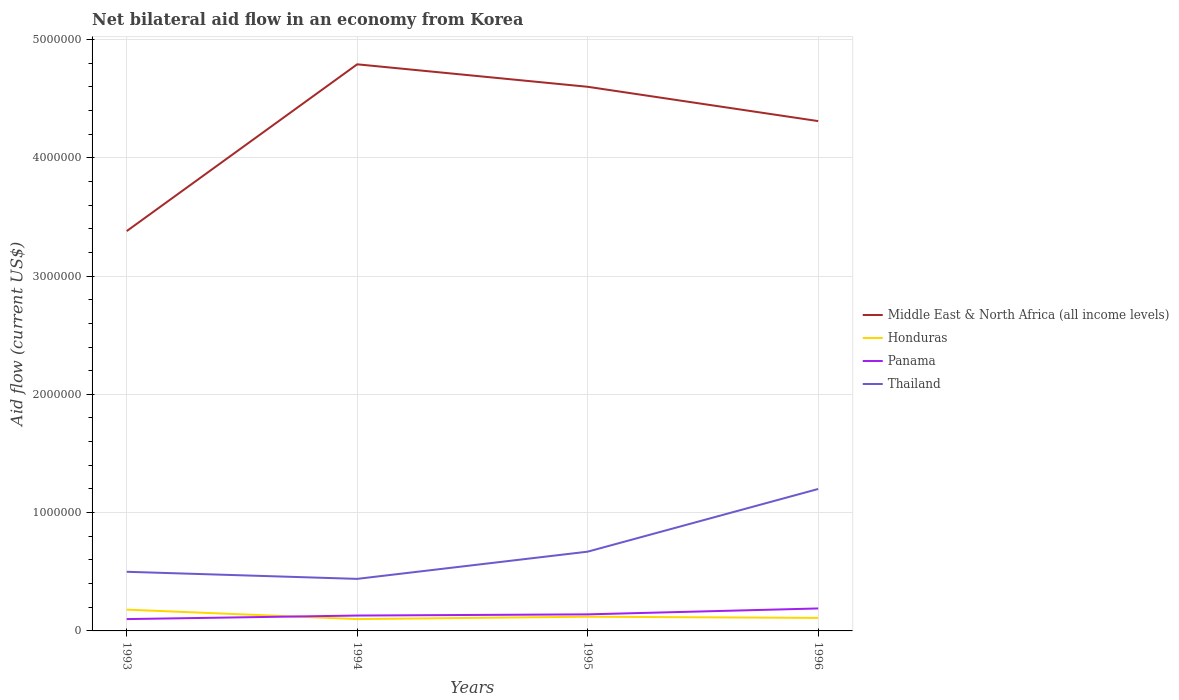In which year was the net bilateral aid flow in Panama maximum?
Keep it short and to the point. 1993. What is the total net bilateral aid flow in Panama in the graph?
Keep it short and to the point. -10000. How many lines are there?
Offer a terse response. 4. What is the difference between two consecutive major ticks on the Y-axis?
Your answer should be very brief. 1.00e+06. Does the graph contain any zero values?
Offer a terse response. No. What is the title of the graph?
Give a very brief answer. Net bilateral aid flow in an economy from Korea. Does "High income: OECD" appear as one of the legend labels in the graph?
Offer a terse response. No. What is the label or title of the Y-axis?
Give a very brief answer. Aid flow (current US$). What is the Aid flow (current US$) in Middle East & North Africa (all income levels) in 1993?
Provide a succinct answer. 3.38e+06. What is the Aid flow (current US$) of Panama in 1993?
Make the answer very short. 1.00e+05. What is the Aid flow (current US$) of Middle East & North Africa (all income levels) in 1994?
Offer a very short reply. 4.79e+06. What is the Aid flow (current US$) of Panama in 1994?
Your response must be concise. 1.30e+05. What is the Aid flow (current US$) in Middle East & North Africa (all income levels) in 1995?
Provide a short and direct response. 4.60e+06. What is the Aid flow (current US$) in Honduras in 1995?
Ensure brevity in your answer.  1.20e+05. What is the Aid flow (current US$) in Panama in 1995?
Provide a succinct answer. 1.40e+05. What is the Aid flow (current US$) of Thailand in 1995?
Provide a succinct answer. 6.70e+05. What is the Aid flow (current US$) of Middle East & North Africa (all income levels) in 1996?
Provide a short and direct response. 4.31e+06. What is the Aid flow (current US$) of Thailand in 1996?
Your answer should be compact. 1.20e+06. Across all years, what is the maximum Aid flow (current US$) in Middle East & North Africa (all income levels)?
Provide a succinct answer. 4.79e+06. Across all years, what is the maximum Aid flow (current US$) of Panama?
Provide a short and direct response. 1.90e+05. Across all years, what is the maximum Aid flow (current US$) in Thailand?
Your response must be concise. 1.20e+06. Across all years, what is the minimum Aid flow (current US$) in Middle East & North Africa (all income levels)?
Provide a succinct answer. 3.38e+06. Across all years, what is the minimum Aid flow (current US$) of Honduras?
Your answer should be compact. 1.00e+05. Across all years, what is the minimum Aid flow (current US$) of Panama?
Give a very brief answer. 1.00e+05. What is the total Aid flow (current US$) of Middle East & North Africa (all income levels) in the graph?
Make the answer very short. 1.71e+07. What is the total Aid flow (current US$) of Honduras in the graph?
Offer a very short reply. 5.10e+05. What is the total Aid flow (current US$) in Panama in the graph?
Keep it short and to the point. 5.60e+05. What is the total Aid flow (current US$) in Thailand in the graph?
Offer a very short reply. 2.81e+06. What is the difference between the Aid flow (current US$) in Middle East & North Africa (all income levels) in 1993 and that in 1994?
Keep it short and to the point. -1.41e+06. What is the difference between the Aid flow (current US$) of Panama in 1993 and that in 1994?
Your answer should be compact. -3.00e+04. What is the difference between the Aid flow (current US$) of Middle East & North Africa (all income levels) in 1993 and that in 1995?
Your answer should be very brief. -1.22e+06. What is the difference between the Aid flow (current US$) in Panama in 1993 and that in 1995?
Ensure brevity in your answer.  -4.00e+04. What is the difference between the Aid flow (current US$) in Thailand in 1993 and that in 1995?
Your response must be concise. -1.70e+05. What is the difference between the Aid flow (current US$) in Middle East & North Africa (all income levels) in 1993 and that in 1996?
Offer a terse response. -9.30e+05. What is the difference between the Aid flow (current US$) of Panama in 1993 and that in 1996?
Offer a very short reply. -9.00e+04. What is the difference between the Aid flow (current US$) of Thailand in 1993 and that in 1996?
Your response must be concise. -7.00e+05. What is the difference between the Aid flow (current US$) of Middle East & North Africa (all income levels) in 1994 and that in 1995?
Provide a succinct answer. 1.90e+05. What is the difference between the Aid flow (current US$) of Honduras in 1994 and that in 1995?
Your answer should be very brief. -2.00e+04. What is the difference between the Aid flow (current US$) in Thailand in 1994 and that in 1995?
Provide a short and direct response. -2.30e+05. What is the difference between the Aid flow (current US$) in Honduras in 1994 and that in 1996?
Provide a short and direct response. -10000. What is the difference between the Aid flow (current US$) of Panama in 1994 and that in 1996?
Offer a terse response. -6.00e+04. What is the difference between the Aid flow (current US$) in Thailand in 1994 and that in 1996?
Provide a short and direct response. -7.60e+05. What is the difference between the Aid flow (current US$) of Honduras in 1995 and that in 1996?
Ensure brevity in your answer.  10000. What is the difference between the Aid flow (current US$) in Thailand in 1995 and that in 1996?
Ensure brevity in your answer.  -5.30e+05. What is the difference between the Aid flow (current US$) of Middle East & North Africa (all income levels) in 1993 and the Aid flow (current US$) of Honduras in 1994?
Offer a terse response. 3.28e+06. What is the difference between the Aid flow (current US$) in Middle East & North Africa (all income levels) in 1993 and the Aid flow (current US$) in Panama in 1994?
Ensure brevity in your answer.  3.25e+06. What is the difference between the Aid flow (current US$) in Middle East & North Africa (all income levels) in 1993 and the Aid flow (current US$) in Thailand in 1994?
Keep it short and to the point. 2.94e+06. What is the difference between the Aid flow (current US$) of Middle East & North Africa (all income levels) in 1993 and the Aid flow (current US$) of Honduras in 1995?
Keep it short and to the point. 3.26e+06. What is the difference between the Aid flow (current US$) of Middle East & North Africa (all income levels) in 1993 and the Aid flow (current US$) of Panama in 1995?
Your answer should be compact. 3.24e+06. What is the difference between the Aid flow (current US$) of Middle East & North Africa (all income levels) in 1993 and the Aid flow (current US$) of Thailand in 1995?
Your answer should be very brief. 2.71e+06. What is the difference between the Aid flow (current US$) of Honduras in 1993 and the Aid flow (current US$) of Thailand in 1995?
Provide a short and direct response. -4.90e+05. What is the difference between the Aid flow (current US$) in Panama in 1993 and the Aid flow (current US$) in Thailand in 1995?
Your response must be concise. -5.70e+05. What is the difference between the Aid flow (current US$) in Middle East & North Africa (all income levels) in 1993 and the Aid flow (current US$) in Honduras in 1996?
Offer a very short reply. 3.27e+06. What is the difference between the Aid flow (current US$) in Middle East & North Africa (all income levels) in 1993 and the Aid flow (current US$) in Panama in 1996?
Give a very brief answer. 3.19e+06. What is the difference between the Aid flow (current US$) in Middle East & North Africa (all income levels) in 1993 and the Aid flow (current US$) in Thailand in 1996?
Your response must be concise. 2.18e+06. What is the difference between the Aid flow (current US$) in Honduras in 1993 and the Aid flow (current US$) in Panama in 1996?
Your response must be concise. -10000. What is the difference between the Aid flow (current US$) in Honduras in 1993 and the Aid flow (current US$) in Thailand in 1996?
Your answer should be very brief. -1.02e+06. What is the difference between the Aid flow (current US$) in Panama in 1993 and the Aid flow (current US$) in Thailand in 1996?
Offer a terse response. -1.10e+06. What is the difference between the Aid flow (current US$) in Middle East & North Africa (all income levels) in 1994 and the Aid flow (current US$) in Honduras in 1995?
Give a very brief answer. 4.67e+06. What is the difference between the Aid flow (current US$) in Middle East & North Africa (all income levels) in 1994 and the Aid flow (current US$) in Panama in 1995?
Keep it short and to the point. 4.65e+06. What is the difference between the Aid flow (current US$) of Middle East & North Africa (all income levels) in 1994 and the Aid flow (current US$) of Thailand in 1995?
Ensure brevity in your answer.  4.12e+06. What is the difference between the Aid flow (current US$) of Honduras in 1994 and the Aid flow (current US$) of Panama in 1995?
Provide a succinct answer. -4.00e+04. What is the difference between the Aid flow (current US$) of Honduras in 1994 and the Aid flow (current US$) of Thailand in 1995?
Offer a terse response. -5.70e+05. What is the difference between the Aid flow (current US$) of Panama in 1994 and the Aid flow (current US$) of Thailand in 1995?
Offer a very short reply. -5.40e+05. What is the difference between the Aid flow (current US$) in Middle East & North Africa (all income levels) in 1994 and the Aid flow (current US$) in Honduras in 1996?
Keep it short and to the point. 4.68e+06. What is the difference between the Aid flow (current US$) in Middle East & North Africa (all income levels) in 1994 and the Aid flow (current US$) in Panama in 1996?
Keep it short and to the point. 4.60e+06. What is the difference between the Aid flow (current US$) in Middle East & North Africa (all income levels) in 1994 and the Aid flow (current US$) in Thailand in 1996?
Offer a terse response. 3.59e+06. What is the difference between the Aid flow (current US$) in Honduras in 1994 and the Aid flow (current US$) in Panama in 1996?
Keep it short and to the point. -9.00e+04. What is the difference between the Aid flow (current US$) of Honduras in 1994 and the Aid flow (current US$) of Thailand in 1996?
Offer a terse response. -1.10e+06. What is the difference between the Aid flow (current US$) of Panama in 1994 and the Aid flow (current US$) of Thailand in 1996?
Provide a short and direct response. -1.07e+06. What is the difference between the Aid flow (current US$) in Middle East & North Africa (all income levels) in 1995 and the Aid flow (current US$) in Honduras in 1996?
Offer a very short reply. 4.49e+06. What is the difference between the Aid flow (current US$) of Middle East & North Africa (all income levels) in 1995 and the Aid flow (current US$) of Panama in 1996?
Your answer should be very brief. 4.41e+06. What is the difference between the Aid flow (current US$) in Middle East & North Africa (all income levels) in 1995 and the Aid flow (current US$) in Thailand in 1996?
Ensure brevity in your answer.  3.40e+06. What is the difference between the Aid flow (current US$) in Honduras in 1995 and the Aid flow (current US$) in Thailand in 1996?
Give a very brief answer. -1.08e+06. What is the difference between the Aid flow (current US$) in Panama in 1995 and the Aid flow (current US$) in Thailand in 1996?
Provide a succinct answer. -1.06e+06. What is the average Aid flow (current US$) of Middle East & North Africa (all income levels) per year?
Offer a terse response. 4.27e+06. What is the average Aid flow (current US$) in Honduras per year?
Your answer should be very brief. 1.28e+05. What is the average Aid flow (current US$) of Thailand per year?
Your answer should be compact. 7.02e+05. In the year 1993, what is the difference between the Aid flow (current US$) in Middle East & North Africa (all income levels) and Aid flow (current US$) in Honduras?
Ensure brevity in your answer.  3.20e+06. In the year 1993, what is the difference between the Aid flow (current US$) in Middle East & North Africa (all income levels) and Aid flow (current US$) in Panama?
Provide a short and direct response. 3.28e+06. In the year 1993, what is the difference between the Aid flow (current US$) of Middle East & North Africa (all income levels) and Aid flow (current US$) of Thailand?
Your answer should be compact. 2.88e+06. In the year 1993, what is the difference between the Aid flow (current US$) of Honduras and Aid flow (current US$) of Panama?
Your response must be concise. 8.00e+04. In the year 1993, what is the difference between the Aid flow (current US$) in Honduras and Aid flow (current US$) in Thailand?
Offer a terse response. -3.20e+05. In the year 1993, what is the difference between the Aid flow (current US$) in Panama and Aid flow (current US$) in Thailand?
Make the answer very short. -4.00e+05. In the year 1994, what is the difference between the Aid flow (current US$) in Middle East & North Africa (all income levels) and Aid flow (current US$) in Honduras?
Provide a short and direct response. 4.69e+06. In the year 1994, what is the difference between the Aid flow (current US$) of Middle East & North Africa (all income levels) and Aid flow (current US$) of Panama?
Offer a very short reply. 4.66e+06. In the year 1994, what is the difference between the Aid flow (current US$) in Middle East & North Africa (all income levels) and Aid flow (current US$) in Thailand?
Give a very brief answer. 4.35e+06. In the year 1994, what is the difference between the Aid flow (current US$) in Honduras and Aid flow (current US$) in Thailand?
Give a very brief answer. -3.40e+05. In the year 1994, what is the difference between the Aid flow (current US$) of Panama and Aid flow (current US$) of Thailand?
Provide a succinct answer. -3.10e+05. In the year 1995, what is the difference between the Aid flow (current US$) of Middle East & North Africa (all income levels) and Aid flow (current US$) of Honduras?
Give a very brief answer. 4.48e+06. In the year 1995, what is the difference between the Aid flow (current US$) in Middle East & North Africa (all income levels) and Aid flow (current US$) in Panama?
Keep it short and to the point. 4.46e+06. In the year 1995, what is the difference between the Aid flow (current US$) in Middle East & North Africa (all income levels) and Aid flow (current US$) in Thailand?
Your answer should be compact. 3.93e+06. In the year 1995, what is the difference between the Aid flow (current US$) in Honduras and Aid flow (current US$) in Thailand?
Ensure brevity in your answer.  -5.50e+05. In the year 1995, what is the difference between the Aid flow (current US$) in Panama and Aid flow (current US$) in Thailand?
Provide a short and direct response. -5.30e+05. In the year 1996, what is the difference between the Aid flow (current US$) in Middle East & North Africa (all income levels) and Aid flow (current US$) in Honduras?
Make the answer very short. 4.20e+06. In the year 1996, what is the difference between the Aid flow (current US$) of Middle East & North Africa (all income levels) and Aid flow (current US$) of Panama?
Give a very brief answer. 4.12e+06. In the year 1996, what is the difference between the Aid flow (current US$) in Middle East & North Africa (all income levels) and Aid flow (current US$) in Thailand?
Give a very brief answer. 3.11e+06. In the year 1996, what is the difference between the Aid flow (current US$) of Honduras and Aid flow (current US$) of Panama?
Offer a terse response. -8.00e+04. In the year 1996, what is the difference between the Aid flow (current US$) of Honduras and Aid flow (current US$) of Thailand?
Your answer should be very brief. -1.09e+06. In the year 1996, what is the difference between the Aid flow (current US$) in Panama and Aid flow (current US$) in Thailand?
Provide a short and direct response. -1.01e+06. What is the ratio of the Aid flow (current US$) in Middle East & North Africa (all income levels) in 1993 to that in 1994?
Offer a very short reply. 0.71. What is the ratio of the Aid flow (current US$) of Honduras in 1993 to that in 1994?
Provide a succinct answer. 1.8. What is the ratio of the Aid flow (current US$) of Panama in 1993 to that in 1994?
Offer a terse response. 0.77. What is the ratio of the Aid flow (current US$) in Thailand in 1993 to that in 1994?
Offer a very short reply. 1.14. What is the ratio of the Aid flow (current US$) of Middle East & North Africa (all income levels) in 1993 to that in 1995?
Ensure brevity in your answer.  0.73. What is the ratio of the Aid flow (current US$) in Honduras in 1993 to that in 1995?
Make the answer very short. 1.5. What is the ratio of the Aid flow (current US$) of Thailand in 1993 to that in 1995?
Give a very brief answer. 0.75. What is the ratio of the Aid flow (current US$) in Middle East & North Africa (all income levels) in 1993 to that in 1996?
Provide a short and direct response. 0.78. What is the ratio of the Aid flow (current US$) in Honduras in 1993 to that in 1996?
Keep it short and to the point. 1.64. What is the ratio of the Aid flow (current US$) of Panama in 1993 to that in 1996?
Provide a succinct answer. 0.53. What is the ratio of the Aid flow (current US$) in Thailand in 1993 to that in 1996?
Give a very brief answer. 0.42. What is the ratio of the Aid flow (current US$) of Middle East & North Africa (all income levels) in 1994 to that in 1995?
Give a very brief answer. 1.04. What is the ratio of the Aid flow (current US$) in Honduras in 1994 to that in 1995?
Give a very brief answer. 0.83. What is the ratio of the Aid flow (current US$) of Thailand in 1994 to that in 1995?
Give a very brief answer. 0.66. What is the ratio of the Aid flow (current US$) in Middle East & North Africa (all income levels) in 1994 to that in 1996?
Offer a terse response. 1.11. What is the ratio of the Aid flow (current US$) of Panama in 1994 to that in 1996?
Offer a very short reply. 0.68. What is the ratio of the Aid flow (current US$) of Thailand in 1994 to that in 1996?
Provide a short and direct response. 0.37. What is the ratio of the Aid flow (current US$) of Middle East & North Africa (all income levels) in 1995 to that in 1996?
Make the answer very short. 1.07. What is the ratio of the Aid flow (current US$) in Panama in 1995 to that in 1996?
Keep it short and to the point. 0.74. What is the ratio of the Aid flow (current US$) of Thailand in 1995 to that in 1996?
Keep it short and to the point. 0.56. What is the difference between the highest and the second highest Aid flow (current US$) of Honduras?
Your response must be concise. 6.00e+04. What is the difference between the highest and the second highest Aid flow (current US$) of Panama?
Your response must be concise. 5.00e+04. What is the difference between the highest and the second highest Aid flow (current US$) of Thailand?
Your answer should be compact. 5.30e+05. What is the difference between the highest and the lowest Aid flow (current US$) in Middle East & North Africa (all income levels)?
Your response must be concise. 1.41e+06. What is the difference between the highest and the lowest Aid flow (current US$) in Honduras?
Your answer should be very brief. 8.00e+04. What is the difference between the highest and the lowest Aid flow (current US$) of Panama?
Offer a terse response. 9.00e+04. What is the difference between the highest and the lowest Aid flow (current US$) of Thailand?
Make the answer very short. 7.60e+05. 